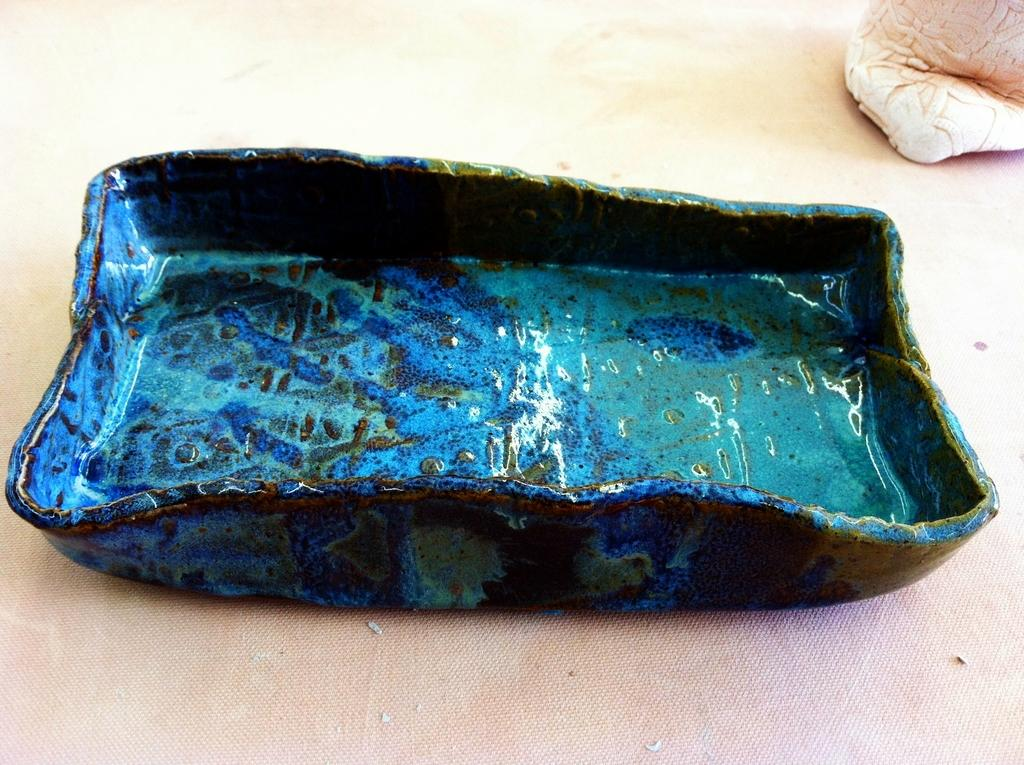What type of bowl is depicted in the image? The bowl is decorative. What color is the decorative bowl? The bowl is bluish in color. Can you describe the object in the top right corner of the image? The object appears to be a cloth. What type of quartz can be seen in the image in the image? There is no quartz present in the image. What is the interest rate of the loan mentioned in the image? There is no mention of a loan or interest rate in the image. 